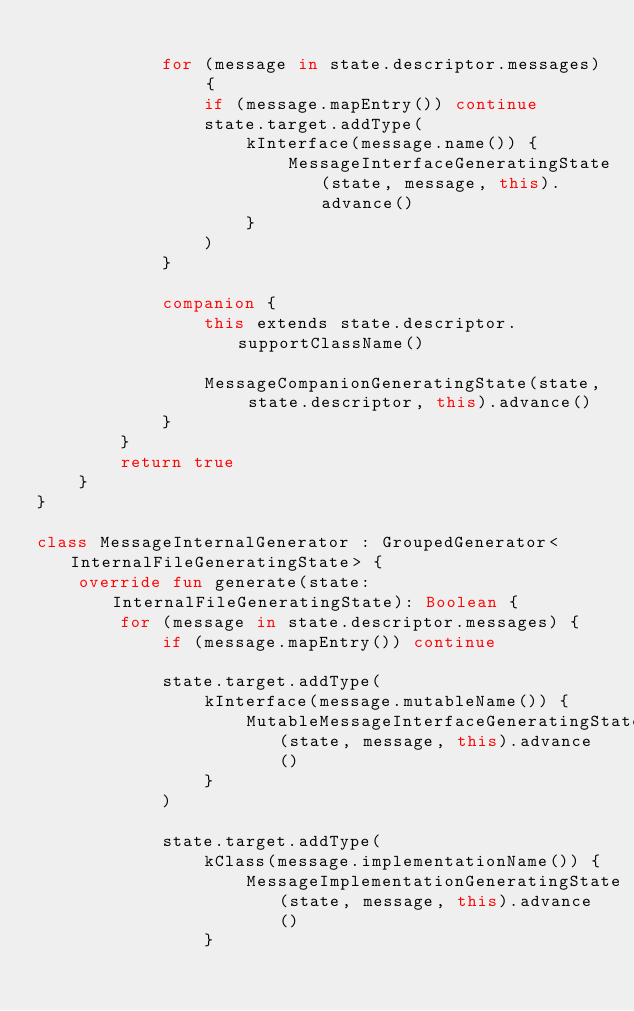<code> <loc_0><loc_0><loc_500><loc_500><_Kotlin_>
            for (message in state.descriptor.messages) {
                if (message.mapEntry()) continue
                state.target.addType(
                    kInterface(message.name()) {
                        MessageInterfaceGeneratingState(state, message, this).advance()
                    }
                )
            }

            companion {
                this extends state.descriptor.supportClassName()

                MessageCompanionGeneratingState(state, state.descriptor, this).advance()
            }
        }
        return true
    }
}

class MessageInternalGenerator : GroupedGenerator<InternalFileGeneratingState> {
    override fun generate(state: InternalFileGeneratingState): Boolean {
        for (message in state.descriptor.messages) {
            if (message.mapEntry()) continue

            state.target.addType(
                kInterface(message.mutableName()) {
                    MutableMessageInterfaceGeneratingState(state, message, this).advance()
                }
            )

            state.target.addType(
                kClass(message.implementationName()) {
                    MessageImplementationGeneratingState(state, message, this).advance()
                }</code> 